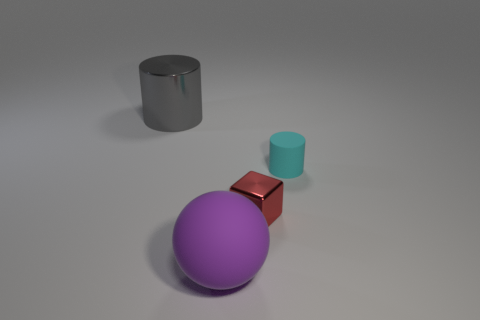Subtract 1 blocks. How many blocks are left? 0 Subtract all green balls. Subtract all yellow cylinders. How many balls are left? 1 Subtract all gray balls. How many cyan cylinders are left? 1 Subtract all small rubber cylinders. Subtract all tiny yellow metal spheres. How many objects are left? 3 Add 2 small shiny things. How many small shiny things are left? 3 Add 3 tiny rubber cylinders. How many tiny rubber cylinders exist? 4 Add 3 balls. How many objects exist? 7 Subtract 1 purple spheres. How many objects are left? 3 